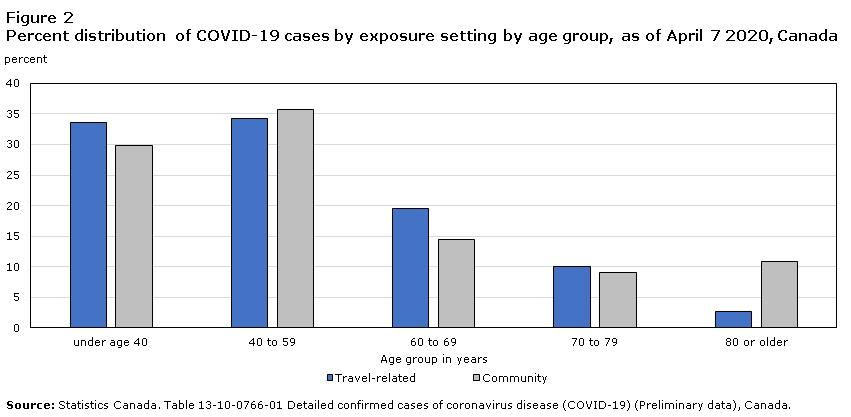List a handful of essential elements in this visual. As of April 7, 2020, in Canada, COVID-19 cases among people aged under 40 years due to community transmission accounted for approximately 30% of the total cases. As of April 7, 2020, less than 5% of COVID-19 cases in the age group of 80 or older in Canada are due to travel-related exposures, according to data. As of April 7, 2020, the percent distribution of COVID-19 cases by community transmission among people in the age group of 40 to 59 in Canada is greater than 35%. As of April 7, 2020, the percent distribution of COVID-19 cases in people aged between 70-79 years due to travel-related exposure in Canada was [insert value]. 